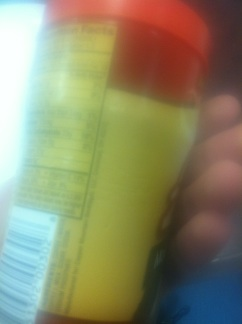Read everything on that please. from Vizwiz The image appears to be blurry and not all text is readable. However, there are some visible sections that seem to be nutritional information or ingredients list on a product, typically found on food or drink items. To provide a more detailed response, clearer or higher quality images should be used. 